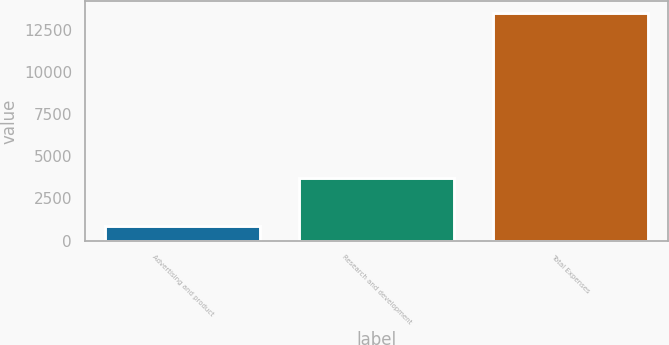Convert chart. <chart><loc_0><loc_0><loc_500><loc_500><bar_chart><fcel>Advertising and product<fcel>Research and development<fcel>Total Expenses<nl><fcel>855<fcel>3731<fcel>13494<nl></chart> 